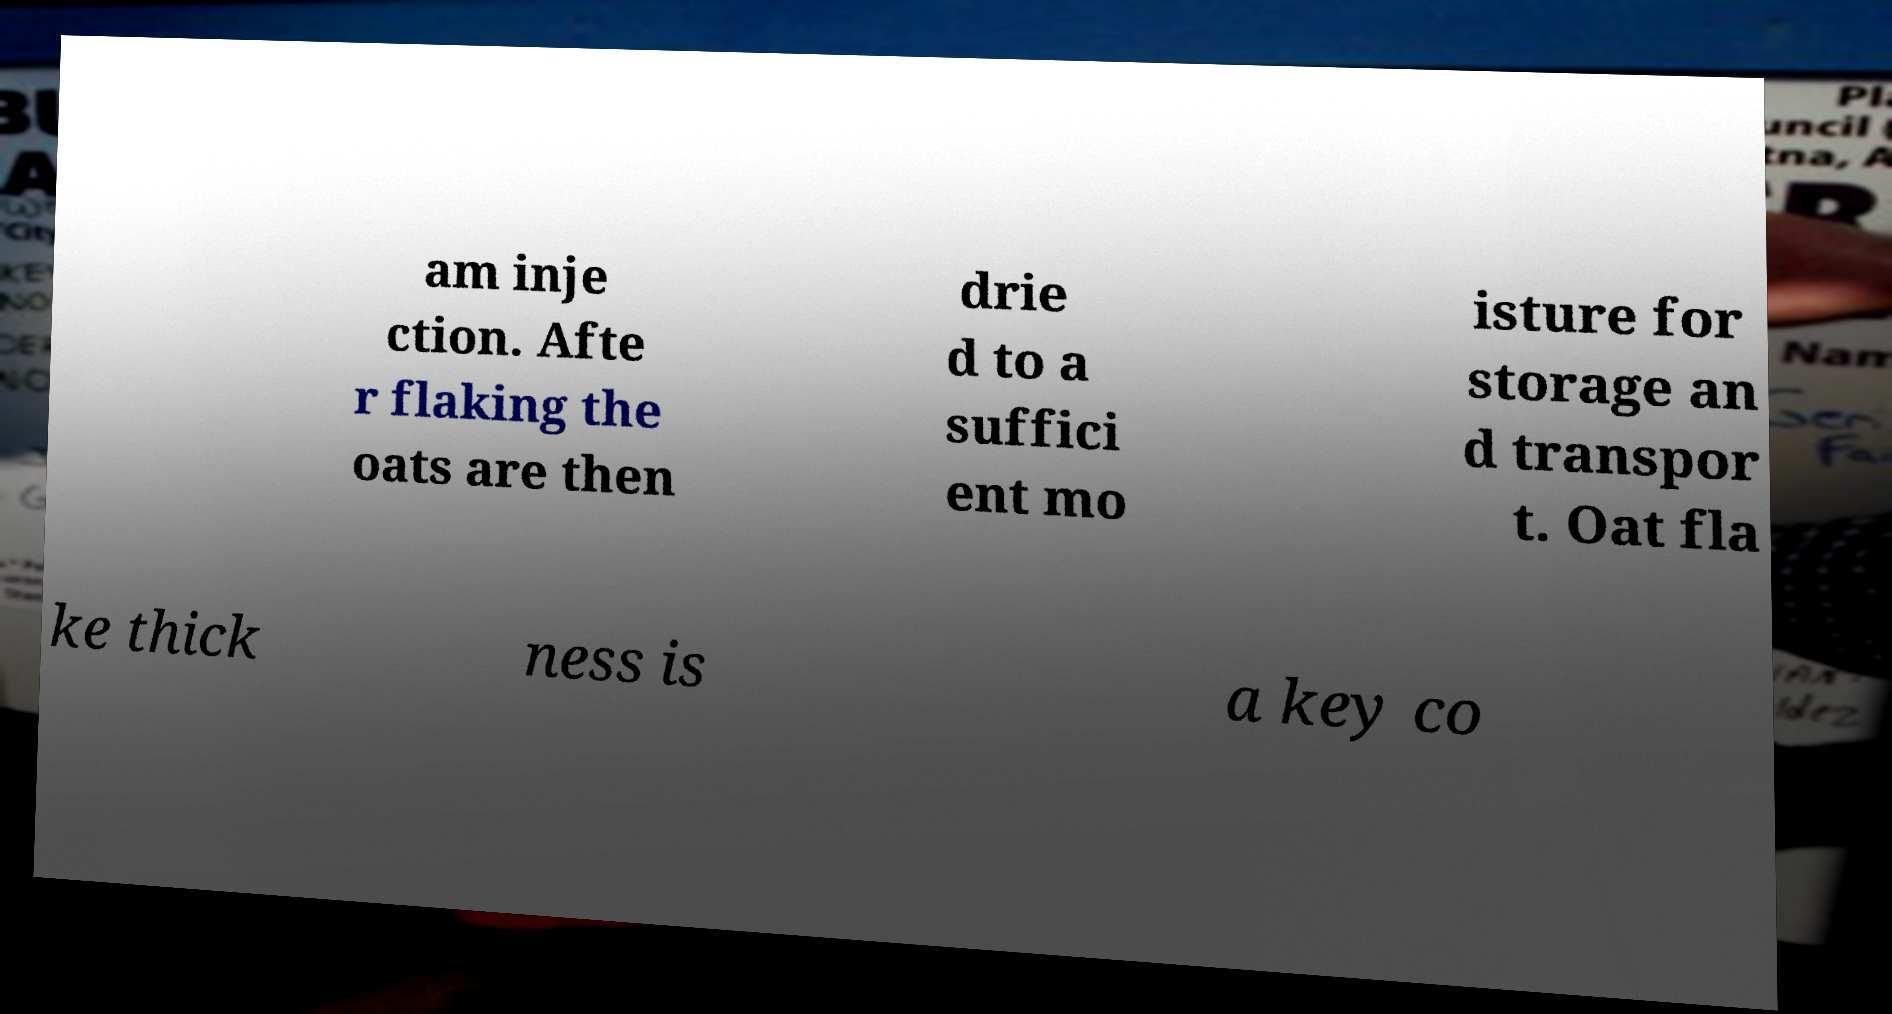Could you extract and type out the text from this image? am inje ction. Afte r flaking the oats are then drie d to a suffici ent mo isture for storage an d transpor t. Oat fla ke thick ness is a key co 